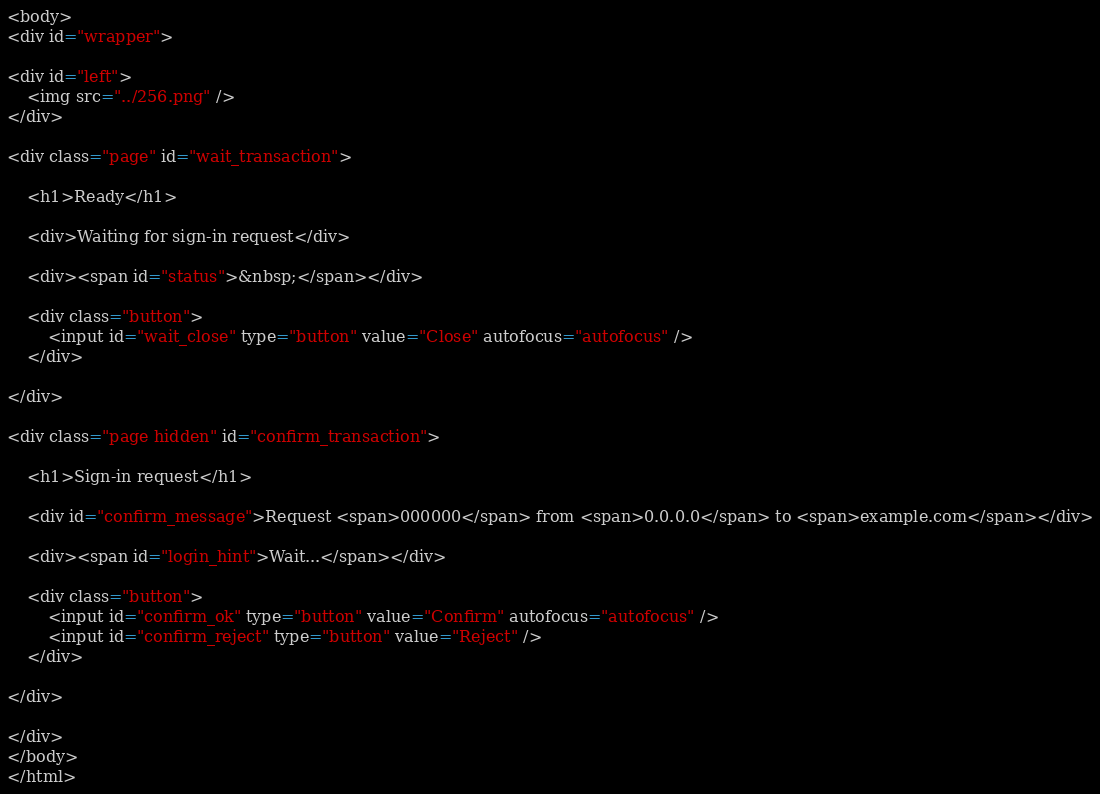<code> <loc_0><loc_0><loc_500><loc_500><_HTML_><body>
<div id="wrapper">

<div id="left">
	<img src="../256.png" />
</div>

<div class="page" id="wait_transaction">

	<h1>Ready</h1>

	<div>Waiting for sign-in request</div>

	<div><span id="status">&nbsp;</span></div>

	<div class="button">
		<input id="wait_close" type="button" value="Close" autofocus="autofocus" />
	</div>

</div>

<div class="page hidden" id="confirm_transaction">

	<h1>Sign-in request</h1>

	<div id="confirm_message">Request <span>000000</span> from <span>0.0.0.0</span> to <span>example.com</span></div>

	<div><span id="login_hint">Wait...</span></div>

	<div class="button">
		<input id="confirm_ok" type="button" value="Confirm" autofocus="autofocus" />
		<input id="confirm_reject" type="button" value="Reject" />
	</div>

</div>

</div>
</body>
</html></code> 